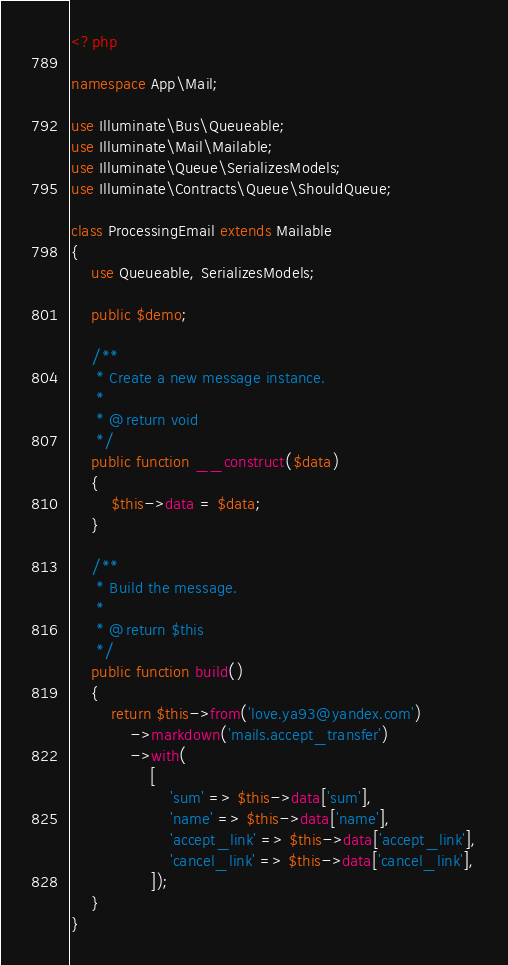<code> <loc_0><loc_0><loc_500><loc_500><_PHP_><?php

namespace App\Mail;

use Illuminate\Bus\Queueable;
use Illuminate\Mail\Mailable;
use Illuminate\Queue\SerializesModels;
use Illuminate\Contracts\Queue\ShouldQueue;

class ProcessingEmail extends Mailable
{
    use Queueable, SerializesModels;

    public $demo;

    /**
     * Create a new message instance.
     *
     * @return void
     */
    public function __construct($data)
    {
        $this->data = $data;
    }

    /**
     * Build the message.
     *
     * @return $this
     */
    public function build()
    {
        return $this->from('love.ya93@yandex.com')
            ->markdown('mails.accept_transfer')
            ->with(
                [
                    'sum' => $this->data['sum'],
                    'name' => $this->data['name'],
                    'accept_link' => $this->data['accept_link'],
                    'cancel_link' => $this->data['cancel_link'],
                ]);
    }
}
</code> 